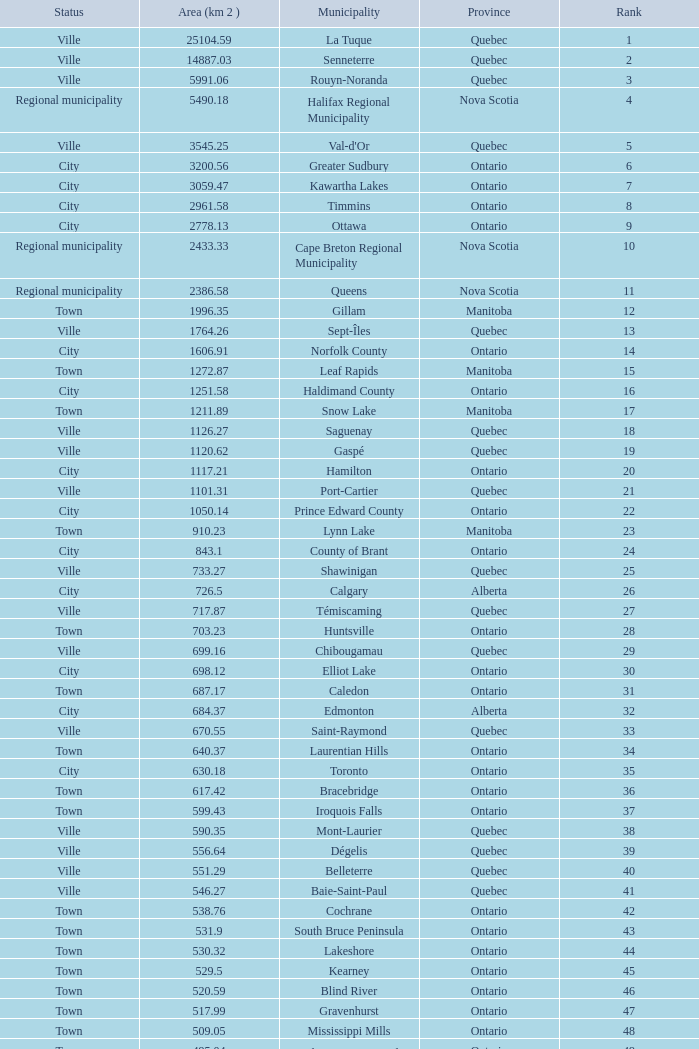What's the total of Rank that has an Area (KM 2) of 1050.14? 22.0. 